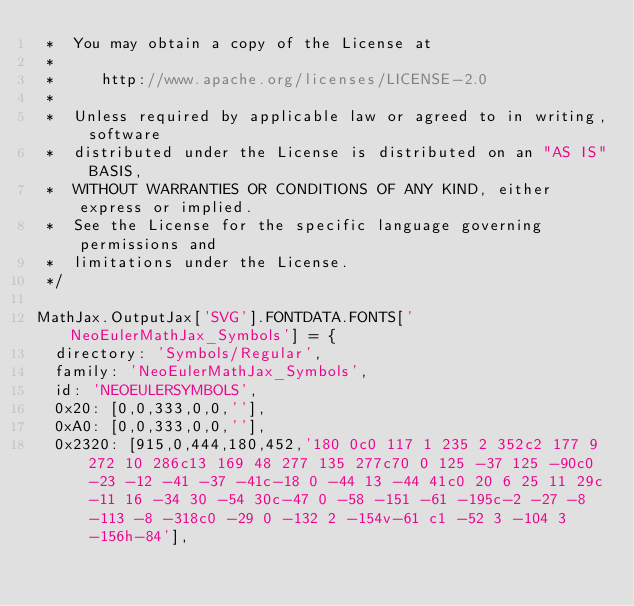<code> <loc_0><loc_0><loc_500><loc_500><_JavaScript_> *  You may obtain a copy of the License at
 *
 *     http://www.apache.org/licenses/LICENSE-2.0
 *
 *  Unless required by applicable law or agreed to in writing, software
 *  distributed under the License is distributed on an "AS IS" BASIS,
 *  WITHOUT WARRANTIES OR CONDITIONS OF ANY KIND, either express or implied.
 *  See the License for the specific language governing permissions and
 *  limitations under the License.
 */

MathJax.OutputJax['SVG'].FONTDATA.FONTS['NeoEulerMathJax_Symbols'] = {
  directory: 'Symbols/Regular',
  family: 'NeoEulerMathJax_Symbols',
  id: 'NEOEULERSYMBOLS',
  0x20: [0,0,333,0,0,''],
  0xA0: [0,0,333,0,0,''],
  0x2320: [915,0,444,180,452,'180 0c0 117 1 235 2 352c2 177 9 272 10 286c13 169 48 277 135 277c70 0 125 -37 125 -90c0 -23 -12 -41 -37 -41c-18 0 -44 13 -44 41c0 20 6 25 11 29c-11 16 -34 30 -54 30c-47 0 -58 -151 -61 -195c-2 -27 -8 -113 -8 -318c0 -29 0 -132 2 -154v-61 c1 -52 3 -104 3 -156h-84'],</code> 